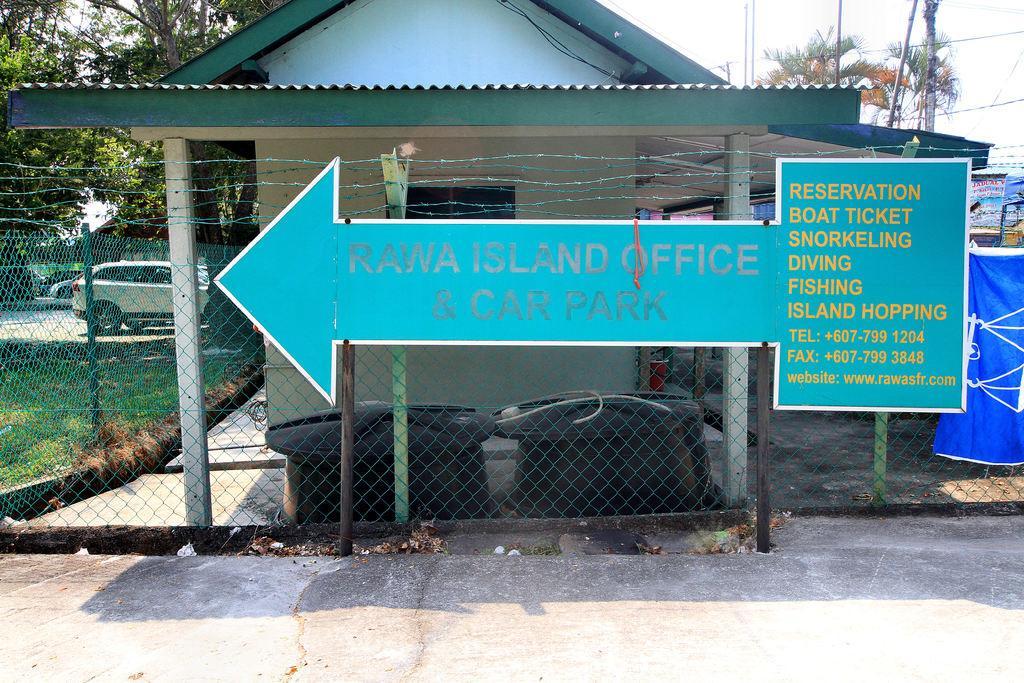How would you summarize this image in a sentence or two? In this image I can see the sign board attached to the fence. In the background I can see the house. To the right I can see the boards and the blue color object. To the left I can see the vehicle. In the background there are trees, pole and the sky. 